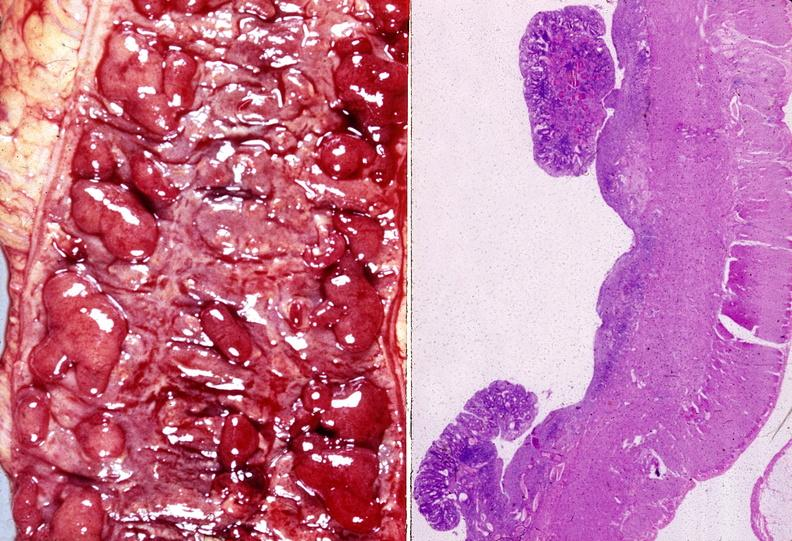does this image show colon, ulcerative colitis?
Answer the question using a single word or phrase. Yes 